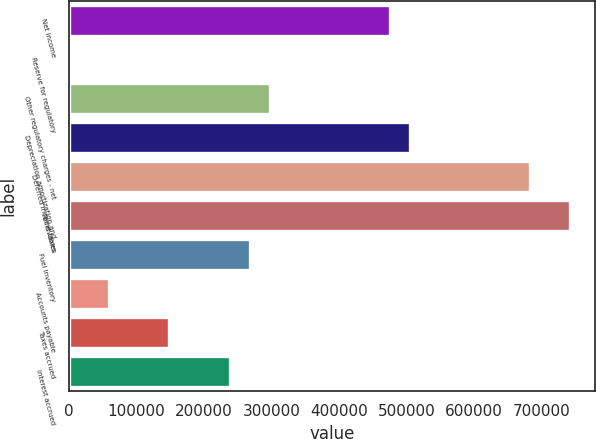<chart> <loc_0><loc_0><loc_500><loc_500><bar_chart><fcel>Net income<fcel>Reserve for regulatory<fcel>Other regulatory charges - net<fcel>Depreciation amortization and<fcel>Deferred income taxes<fcel>Receivables<fcel>Fuel inventory<fcel>Accounts payable<fcel>Taxes accrued<fcel>Interest accrued<nl><fcel>475113<fcel>363<fcel>297082<fcel>504785<fcel>682817<fcel>742160<fcel>267410<fcel>59706.8<fcel>148722<fcel>237738<nl></chart> 